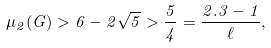Convert formula to latex. <formula><loc_0><loc_0><loc_500><loc_500>\mu _ { 2 } ( G ) > 6 - 2 \sqrt { 5 } > \frac { 5 } { 4 } = \frac { 2 . 3 - 1 } { \ell } ,</formula> 